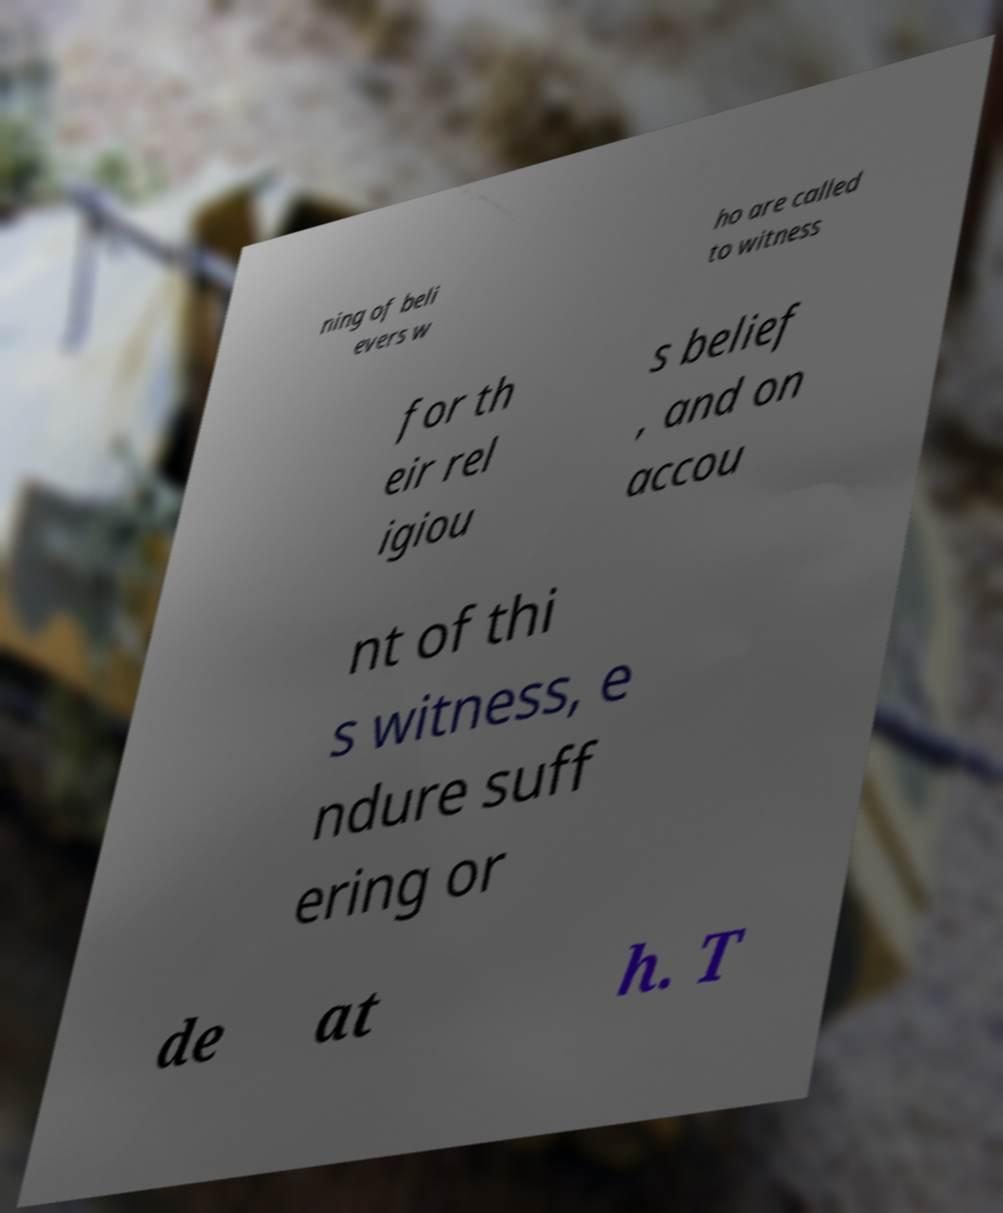Could you assist in decoding the text presented in this image and type it out clearly? ning of beli evers w ho are called to witness for th eir rel igiou s belief , and on accou nt of thi s witness, e ndure suff ering or de at h. T 